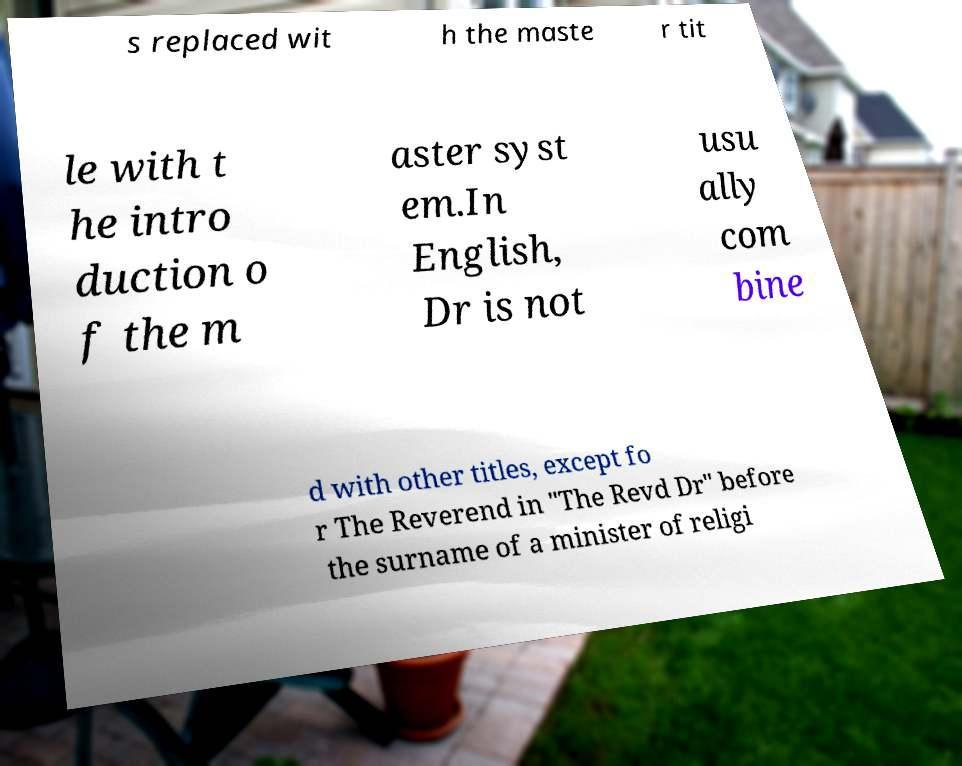I need the written content from this picture converted into text. Can you do that? s replaced wit h the maste r tit le with t he intro duction o f the m aster syst em.In English, Dr is not usu ally com bine d with other titles, except fo r The Reverend in "The Revd Dr" before the surname of a minister of religi 